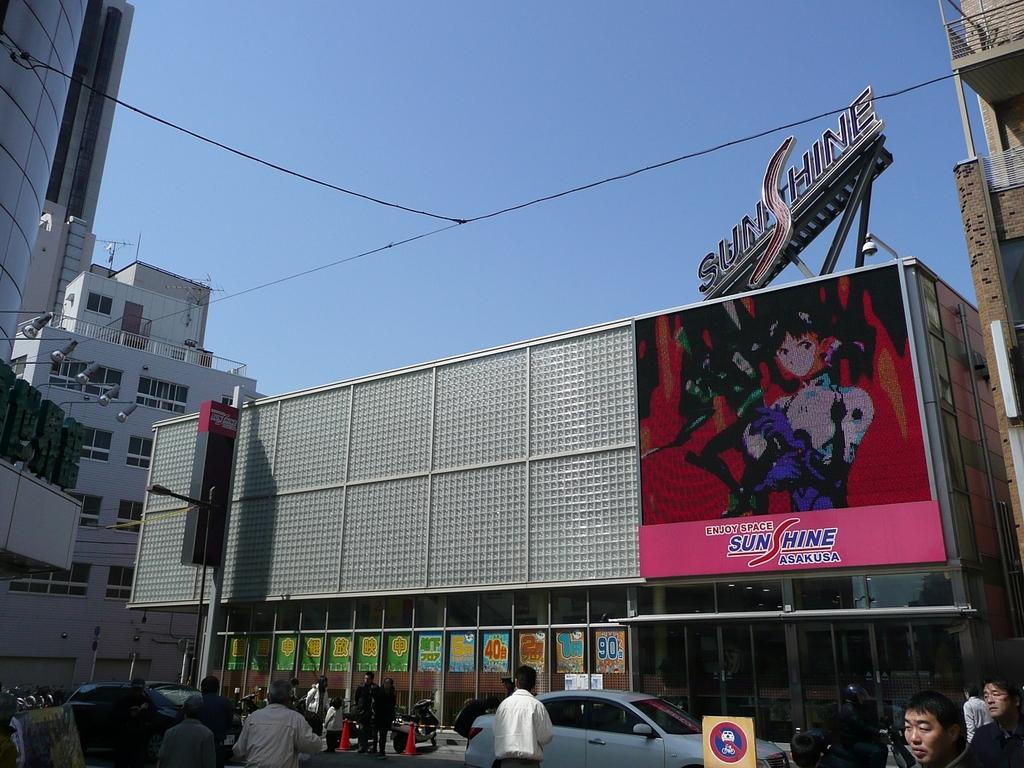<image>
Summarize the visual content of the image. An advertisment with an anime character states to enjoy space. 